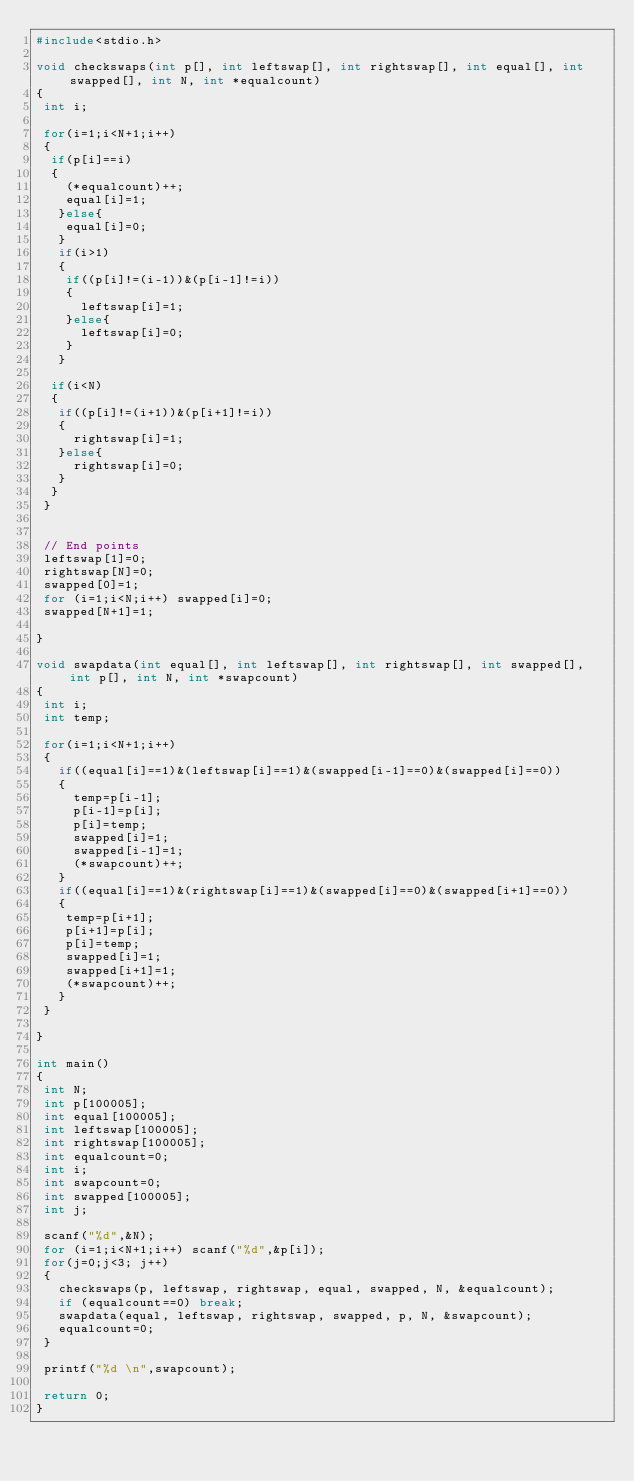Convert code to text. <code><loc_0><loc_0><loc_500><loc_500><_C_>#include<stdio.h>

void checkswaps(int p[], int leftswap[], int rightswap[], int equal[], int swapped[], int N, int *equalcount) 
{
 int i;

 for(i=1;i<N+1;i++)
 {
  if(p[i]==i)
  {
    (*equalcount)++;
    equal[i]=1;
   }else{
    equal[i]=0;
   }
   if(i>1)
   {
    if((p[i]!=(i-1))&(p[i-1]!=i))
    {
      leftswap[i]=1;
    }else{
      leftswap[i]=0;
    }
   }

  if(i<N)
  {
   if((p[i]!=(i+1))&(p[i+1]!=i))
   {
     rightswap[i]=1;
   }else{
     rightswap[i]=0;
   }
  }
 }


 // End points
 leftswap[1]=0;
 rightswap[N]=0;
 swapped[0]=1;
 for (i=1;i<N;i++) swapped[i]=0;
 swapped[N+1]=1;

}

void swapdata(int equal[], int leftswap[], int rightswap[], int swapped[], int p[], int N, int *swapcount)
{
 int i;
 int temp;

 for(i=1;i<N+1;i++)
 {
   if((equal[i]==1)&(leftswap[i]==1)&(swapped[i-1]==0)&(swapped[i]==0))
   {
     temp=p[i-1];
     p[i-1]=p[i];
     p[i]=temp;
     swapped[i]=1;
     swapped[i-1]=1;
     (*swapcount)++;
   }
   if((equal[i]==1)&(rightswap[i]==1)&(swapped[i]==0)&(swapped[i+1]==0))
   {
    temp=p[i+1];
    p[i+1]=p[i];
    p[i]=temp;
    swapped[i]=1;
    swapped[i+1]=1;
    (*swapcount)++;
   }
 }

}

int main()
{
 int N;
 int p[100005];
 int equal[100005];
 int leftswap[100005];
 int rightswap[100005];
 int equalcount=0;
 int i;
 int swapcount=0;
 int swapped[100005];
 int j;

 scanf("%d",&N);
 for (i=1;i<N+1;i++) scanf("%d",&p[i]);
 for(j=0;j<3; j++)
 {
   checkswaps(p, leftswap, rightswap, equal, swapped, N, &equalcount);
   if (equalcount==0) break;
   swapdata(equal, leftswap, rightswap, swapped, p, N, &swapcount);
   equalcount=0;
 }

 printf("%d \n",swapcount);

 return 0;
}
</code> 